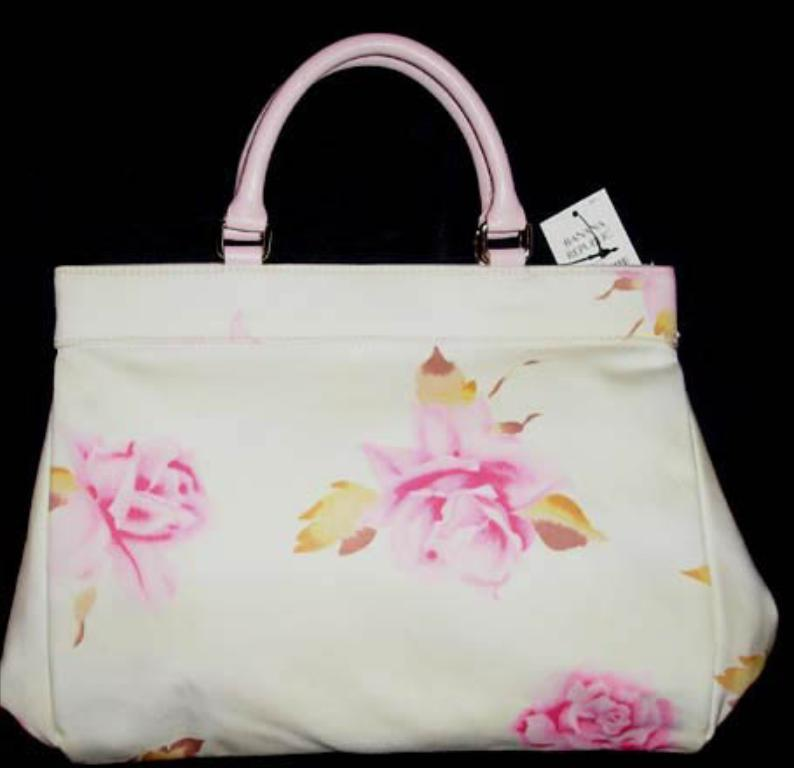What object can be seen in the image? There is a handbag in the image. Is there anything attached to the handbag? Yes, the handbag has a tag attached to it. How many balloons are tied to the handbag in the image? There are no balloons present in the image; it only features a handbag with a tag attached to it. 